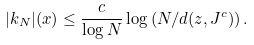<formula> <loc_0><loc_0><loc_500><loc_500>| k _ { N } | ( x ) \leq \frac { c } { \log N } \log \left ( N / d ( z , J ^ { c } ) \right ) .</formula> 